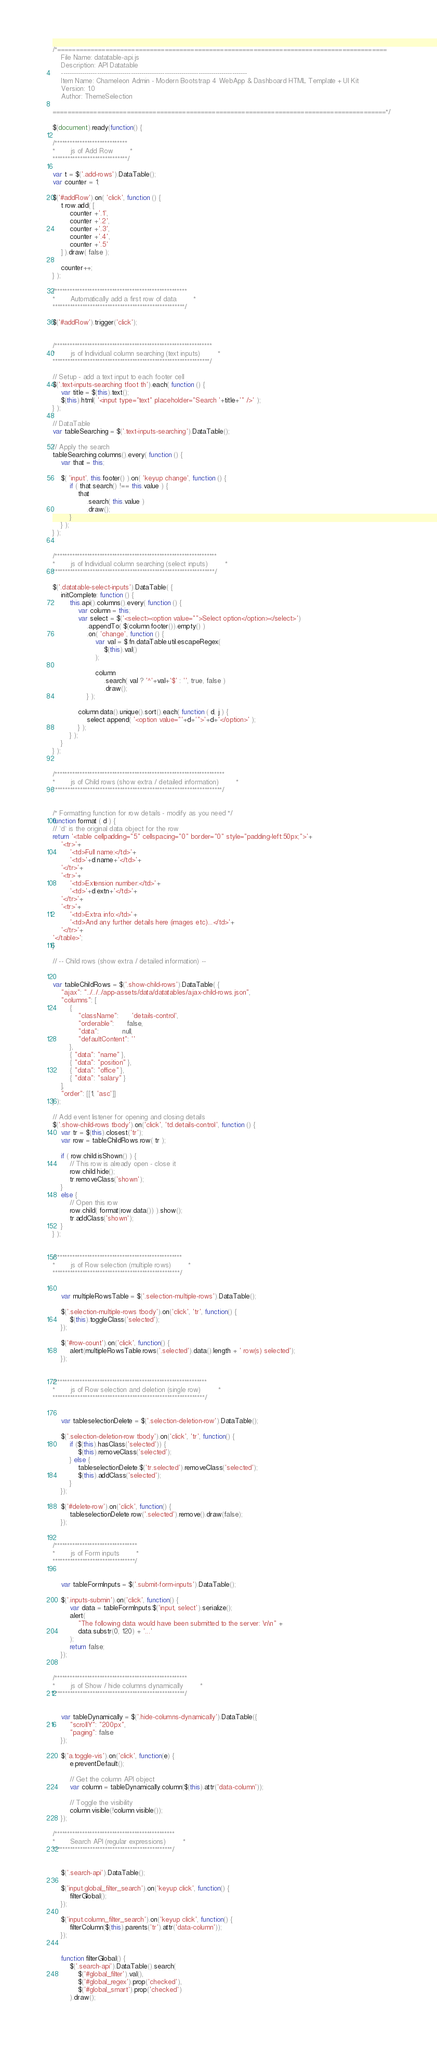Convert code to text. <code><loc_0><loc_0><loc_500><loc_500><_JavaScript_>/*=========================================================================================
    File Name: datatable-api.js
    Description: API Datatable 
    ----------------------------------------------------------------------------------------
    Item Name: Chameleon Admin - Modern Bootstrap 4 WebApp & Dashboard HTML Template + UI Kit
    Version: 1.0
    Author: ThemeSelection
    
==========================================================================================*/

$(document).ready(function() {

/*****************************
*       js of Add Row        *
******************************/

var t = $('.add-rows').DataTable();
var counter = 1;

$('#addRow').on( 'click', function () {
    t.row.add( [
        counter +'.1',
        counter +'.2',
        counter +'.3',
        counter +'.4',
        counter +'.5'
    ] ).draw( false );

    counter++;
} );

/*****************************************************
*       Automatically add a first row of data        *
*****************************************************/

$('#addRow').trigger('click');


/***************************************************************
*       js of Individual column searching (text inputs)        *
***************************************************************/

// Setup - add a text input to each footer cell
$('.text-inputs-searching tfoot th').each( function () {
    var title = $(this).text();
    $(this).html( '<input type="text" placeholder="Search '+title+'" />' );
} );

// DataTable
var tableSearching = $('.text-inputs-searching').DataTable();

// Apply the search
tableSearching.columns().every( function () {
    var that = this;

    $( 'input', this.footer() ).on( 'keyup change', function () {
        if ( that.search() !== this.value ) {
            that
                .search( this.value )
                .draw();
        }
    } );
} );


/*****************************************************************
*       js of Individual column searching (select inputs)        *
*****************************************************************/

$('.datatable-select-inputs').DataTable( {
    initComplete: function () {
        this.api().columns().every( function () {
            var column = this;
            var select = $('<select><option value="">Select option</option></select>')
                .appendTo( $(column.footer()).empty() )
                .on( 'change', function () {
                    var val = $.fn.dataTable.util.escapeRegex(
                        $(this).val()
                    );

                    column
                        .search( val ? '^'+val+'$' : '', true, false )
                        .draw();
                } );

            column.data().unique().sort().each( function ( d, j ) {
                select.append( '<option value="'+d+'">'+d+'</option>' );
            } );
        } );
    }
} );


/********************************************************************
*       js of Child rows (show extra / detailed information)        *
********************************************************************/


/* Formatting function for row details - modify as you need */
function format ( d ) {
// `d` is the original data object for the row
return '<table cellpadding="5" cellspacing="0" border="0" style="padding-left:50px;">'+
    '<tr>'+
        '<td>Full name:</td>'+
        '<td>'+d.name+'</td>'+
    '</tr>'+
    '<tr>'+
        '<td>Extension number:</td>'+
        '<td>'+d.extn+'</td>'+
    '</tr>'+
    '<tr>'+
        '<td>Extra info:</td>'+
        '<td>And any further details here (images etc)...</td>'+
    '</tr>'+
'</table>';
}

// -- Child rows (show extra / detailed information) --


var tableChildRows = $('.show-child-rows').DataTable( {
    "ajax": "../../../app-assets/data/datatables/ajax-child-rows.json",
    "columns": [
        {
            "className":      'details-control',
            "orderable":      false,
            "data":           null,
            "defaultContent": ''
        },
        { "data": "name" },
        { "data": "position" },
        { "data": "office" },
        { "data": "salary" }
    ],
    "order": [[1, 'asc']]
} );

// Add event listener for opening and closing details
$('.show-child-rows tbody').on('click', 'td.details-control', function () {
    var tr = $(this).closest('tr');
    var row = tableChildRows.row( tr );

    if ( row.child.isShown() ) {
        // This row is already open - close it
        row.child.hide();
        tr.removeClass('shown');
    }
    else {
        // Open this row
        row.child( format(row.data()) ).show();
        tr.addClass('shown');
    }
} );


/***************************************************
*       js of Row selection (multiple rows)        *
***************************************************/


    var multipleRowsTable = $('.selection-multiple-rows').DataTable();

    $('.selection-multiple-rows tbody').on('click', 'tr', function() {
        $(this).toggleClass('selected');
    });

    $('#row-count').on('click', function() {
        alert(multipleRowsTable.rows('.selected').data().length + ' row(s) selected');
    });


/*************************************************************
*       js of Row selection and deletion (single row)        *
*************************************************************/


    var tableselectionDelete = $('.selection-deletion-row').DataTable();

    $('.selection-deletion-row tbody').on('click', 'tr', function() {
        if ($(this).hasClass('selected')) {
            $(this).removeClass('selected');
        } else {
            tableselectionDelete.$('tr.selected').removeClass('selected');
            $(this).addClass('selected');
        }
    });

    $('#delete-row').on('click', function() {
        tableselectionDelete.row('.selected').remove().draw(false);
    });


/*********************************
*       js of Form inputs        *
*********************************/


    var tableFormInputs = $('.submit-form-inputs').DataTable();

    $('.inputs-submin').on('click', function() {
        var data = tableFormInputs.$('input, select').serialize();
        alert(
            "The following data would have been submitted to the server: \n\n" +
            data.substr(0, 120) + '...'
        );
        return false;
    });


/*****************************************************
*       js of Show / hide columns dynamically        *
*****************************************************/


    var tableDynamically = $('.hide-columns-dynamically').DataTable({
        "scrollY": "200px",
        "paging": false
    });

    $('a.toggle-vis').on('click', function(e) {
        e.preventDefault();

        // Get the column API object
        var column = tableDynamically.column($(this).attr('data-column'));

        // Toggle the visibility
        column.visible(!column.visible());
    });

/************************************************
*       Search API (regular expressions)        *
************************************************/


    $('.search-api').DataTable();

    $('input.global_filter_search').on('keyup click', function() {
        filterGlobal();
    });

    $('input.column_filter_search').on('keyup click', function() {
        filterColumn($(this).parents('tr').attr('data-column'));
    });


    function filterGlobal() {
        $('.search-api').DataTable().search(
            $('#global_filter').val(),
            $('#global_regex').prop('checked'),
            $('#global_smart').prop('checked')
        ).draw();</code> 